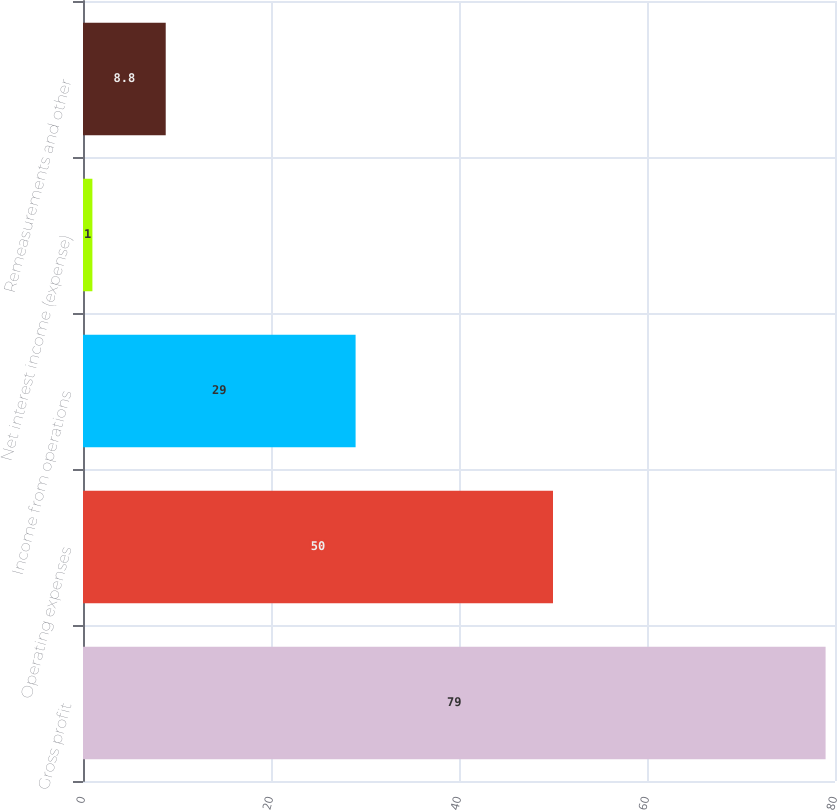Convert chart. <chart><loc_0><loc_0><loc_500><loc_500><bar_chart><fcel>Gross profit<fcel>Operating expenses<fcel>Income from operations<fcel>Net interest income (expense)<fcel>Remeasurements and other<nl><fcel>79<fcel>50<fcel>29<fcel>1<fcel>8.8<nl></chart> 